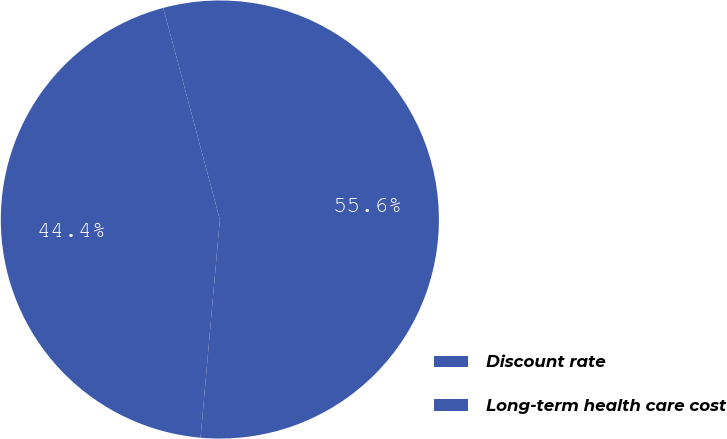Convert chart. <chart><loc_0><loc_0><loc_500><loc_500><pie_chart><fcel>Discount rate<fcel>Long-term health care cost<nl><fcel>55.56%<fcel>44.44%<nl></chart> 